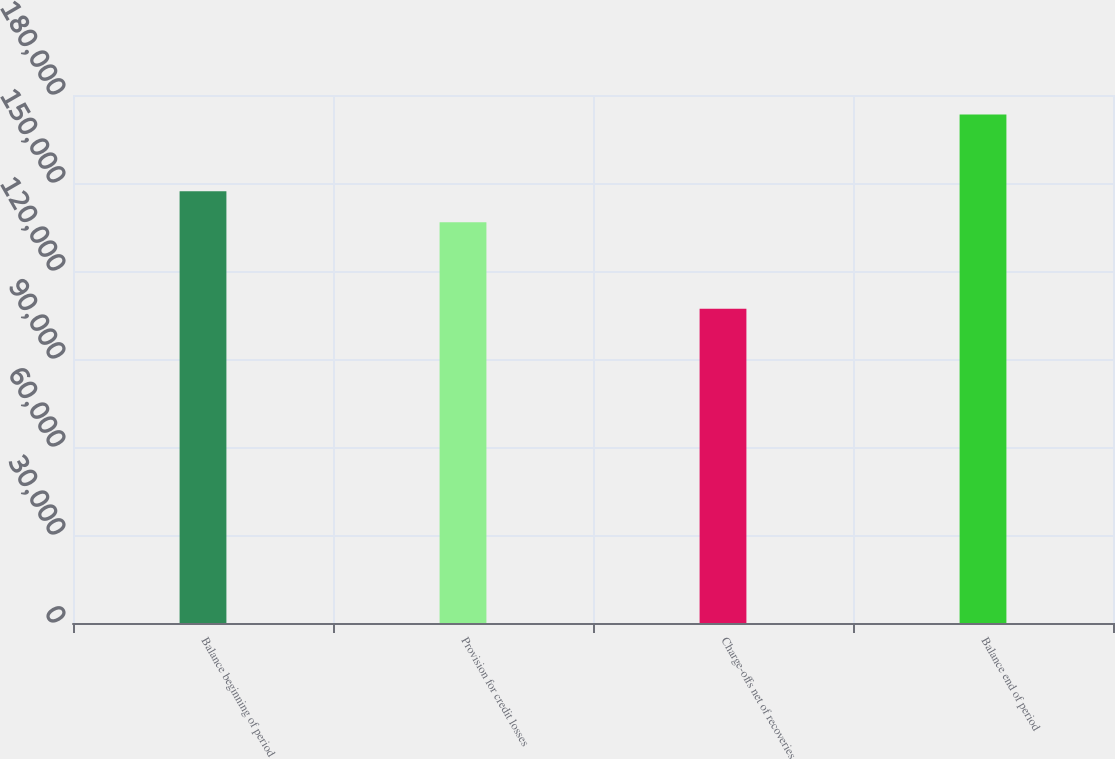Convert chart. <chart><loc_0><loc_0><loc_500><loc_500><bar_chart><fcel>Balance beginning of period<fcel>Provision for credit losses<fcel>Charge-offs net of recoveries<fcel>Balance end of period<nl><fcel>147178<fcel>136617<fcel>107161<fcel>173343<nl></chart> 